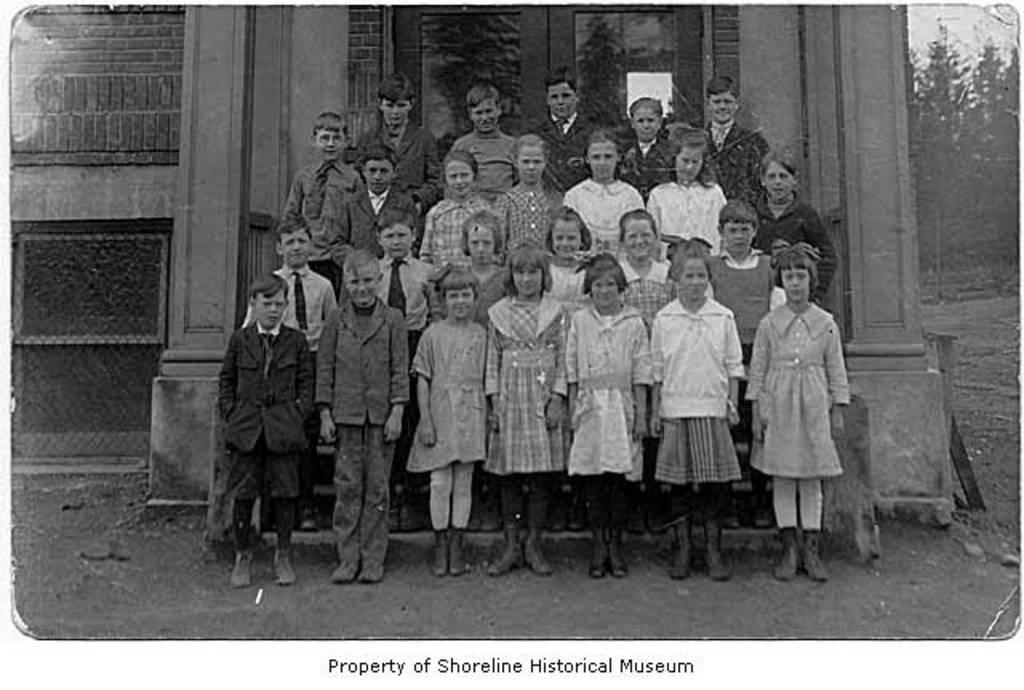What is the color scheme of the image? The image is black and white. What architectural features can be seen in the image? There are pillars, a wall, and a door visible in the image. What type of surface is visible in the image? There is ground visible in the image. What natural elements are present in the image? There are trees in the image. Who is present in the image? There is a group of children in the image. What is written at the bottom of the image? There is text written at the bottom of the image. Can you hear the bell ringing in the image? There is no bell present in the image, so it cannot be heard. What type of dinosaur is playing with the children in the image? There are no dinosaurs present in the image; it features a group of children. 